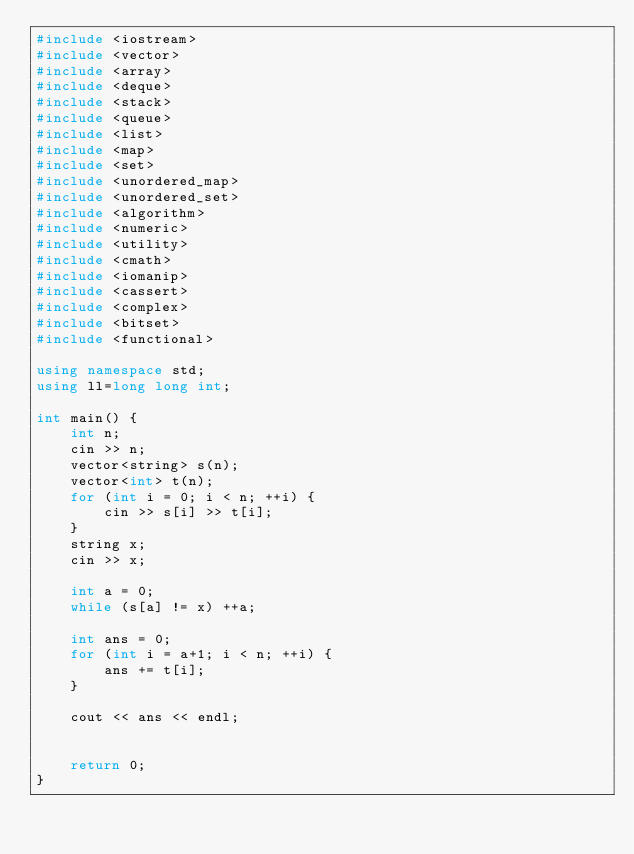<code> <loc_0><loc_0><loc_500><loc_500><_C++_>#include <iostream>
#include <vector>
#include <array>
#include <deque>
#include <stack>
#include <queue>
#include <list>
#include <map>
#include <set>
#include <unordered_map>
#include <unordered_set>
#include <algorithm>
#include <numeric>
#include <utility>
#include <cmath>
#include <iomanip>
#include <cassert>
#include <complex>
#include <bitset>
#include <functional>

using namespace std;
using ll=long long int;

int main() {
    int n;
    cin >> n;
    vector<string> s(n);
    vector<int> t(n);
    for (int i = 0; i < n; ++i) {
        cin >> s[i] >> t[i];
    }
    string x;
    cin >> x;

    int a = 0;
    while (s[a] != x) ++a;

    int ans = 0;
    for (int i = a+1; i < n; ++i) {
        ans += t[i];
    }

    cout << ans << endl;


    return 0;
}
</code> 